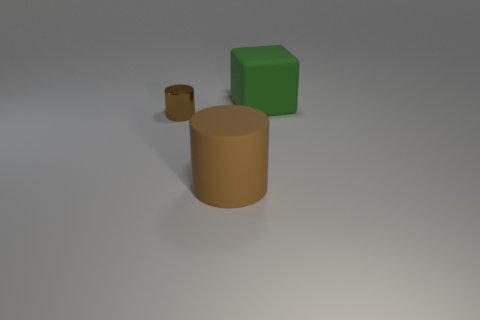Is there any other thing that is made of the same material as the small brown cylinder?
Offer a terse response. No. Are there fewer brown shiny cylinders in front of the metal cylinder than green blocks?
Offer a terse response. Yes. How many other rubber things have the same color as the small thing?
Keep it short and to the point. 1. There is a matte object in front of the cube; what is its size?
Ensure brevity in your answer.  Large. What is the shape of the brown thing behind the brown cylinder that is right of the object to the left of the large brown matte cylinder?
Ensure brevity in your answer.  Cylinder. What shape is the object that is to the right of the tiny brown metal cylinder and in front of the rubber cube?
Ensure brevity in your answer.  Cylinder. Is there a cylinder of the same size as the green rubber thing?
Give a very brief answer. Yes. There is a brown object in front of the tiny brown thing; is its shape the same as the small brown metallic thing?
Provide a succinct answer. Yes. Is the tiny brown thing the same shape as the large brown matte thing?
Your answer should be very brief. Yes. Are there any other small brown objects that have the same shape as the small thing?
Your response must be concise. No. 